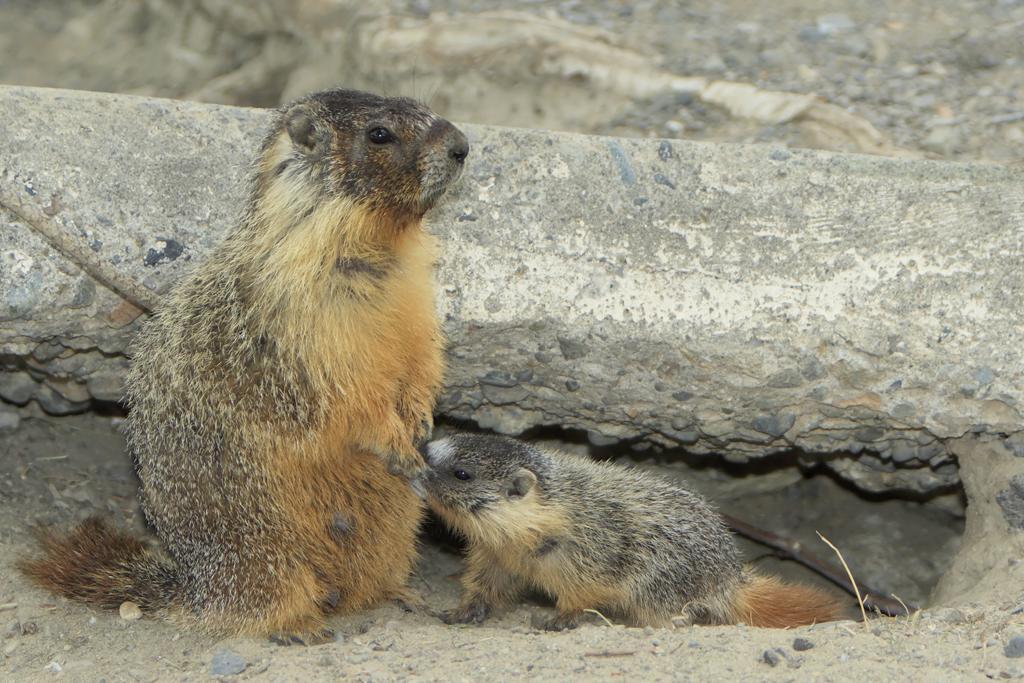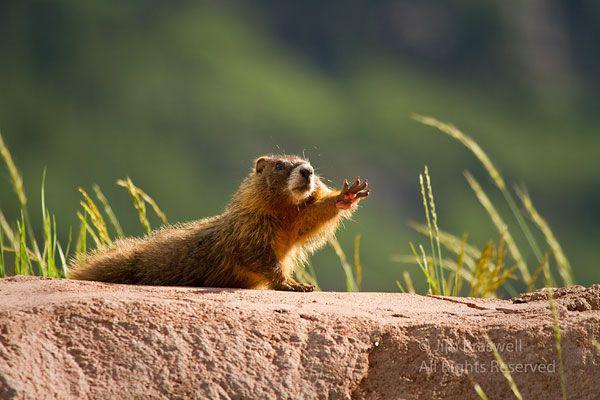The first image is the image on the left, the second image is the image on the right. For the images displayed, is the sentence "In one of the images, there is a marmot standing up on its hind legs" factually correct? Answer yes or no. Yes. 